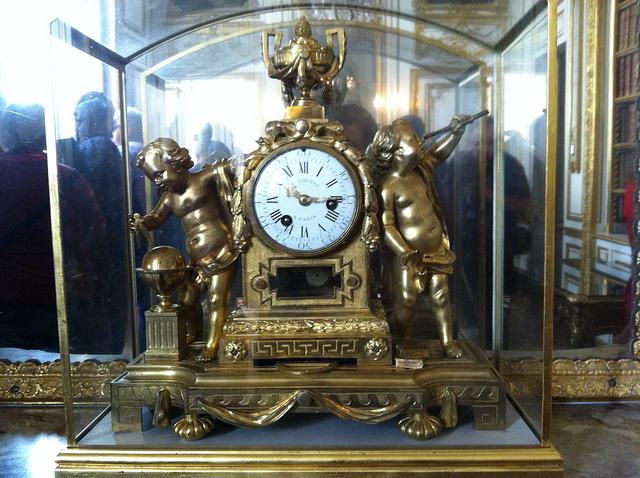What is located behind the clock? mirror 